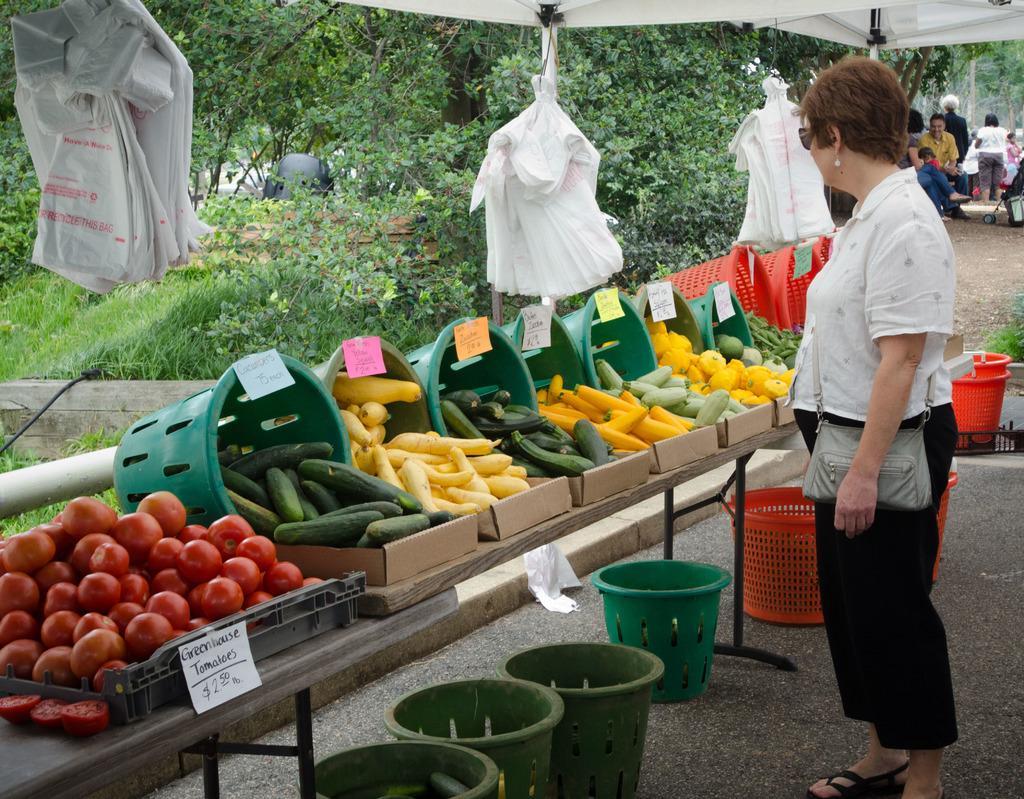Please provide a concise description of this image. In this image we can see few vegetables on the table, there are few labels attached to the baskets and there are few baskets under the table and few bags hanged to the tent and there is a person standing near the table and in the background there are few people and trees. 